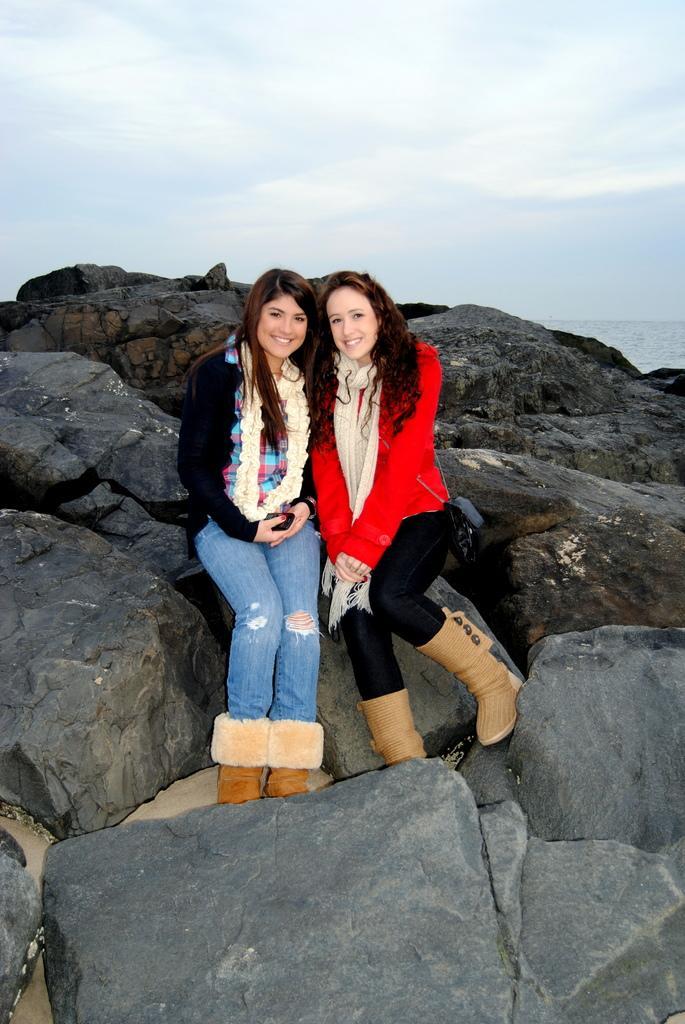How would you summarize this image in a sentence or two? In this image two women are sitting on the rocks. They are wearing jackets and scarf. These women are wearing boots. Top of the image there is sky. 